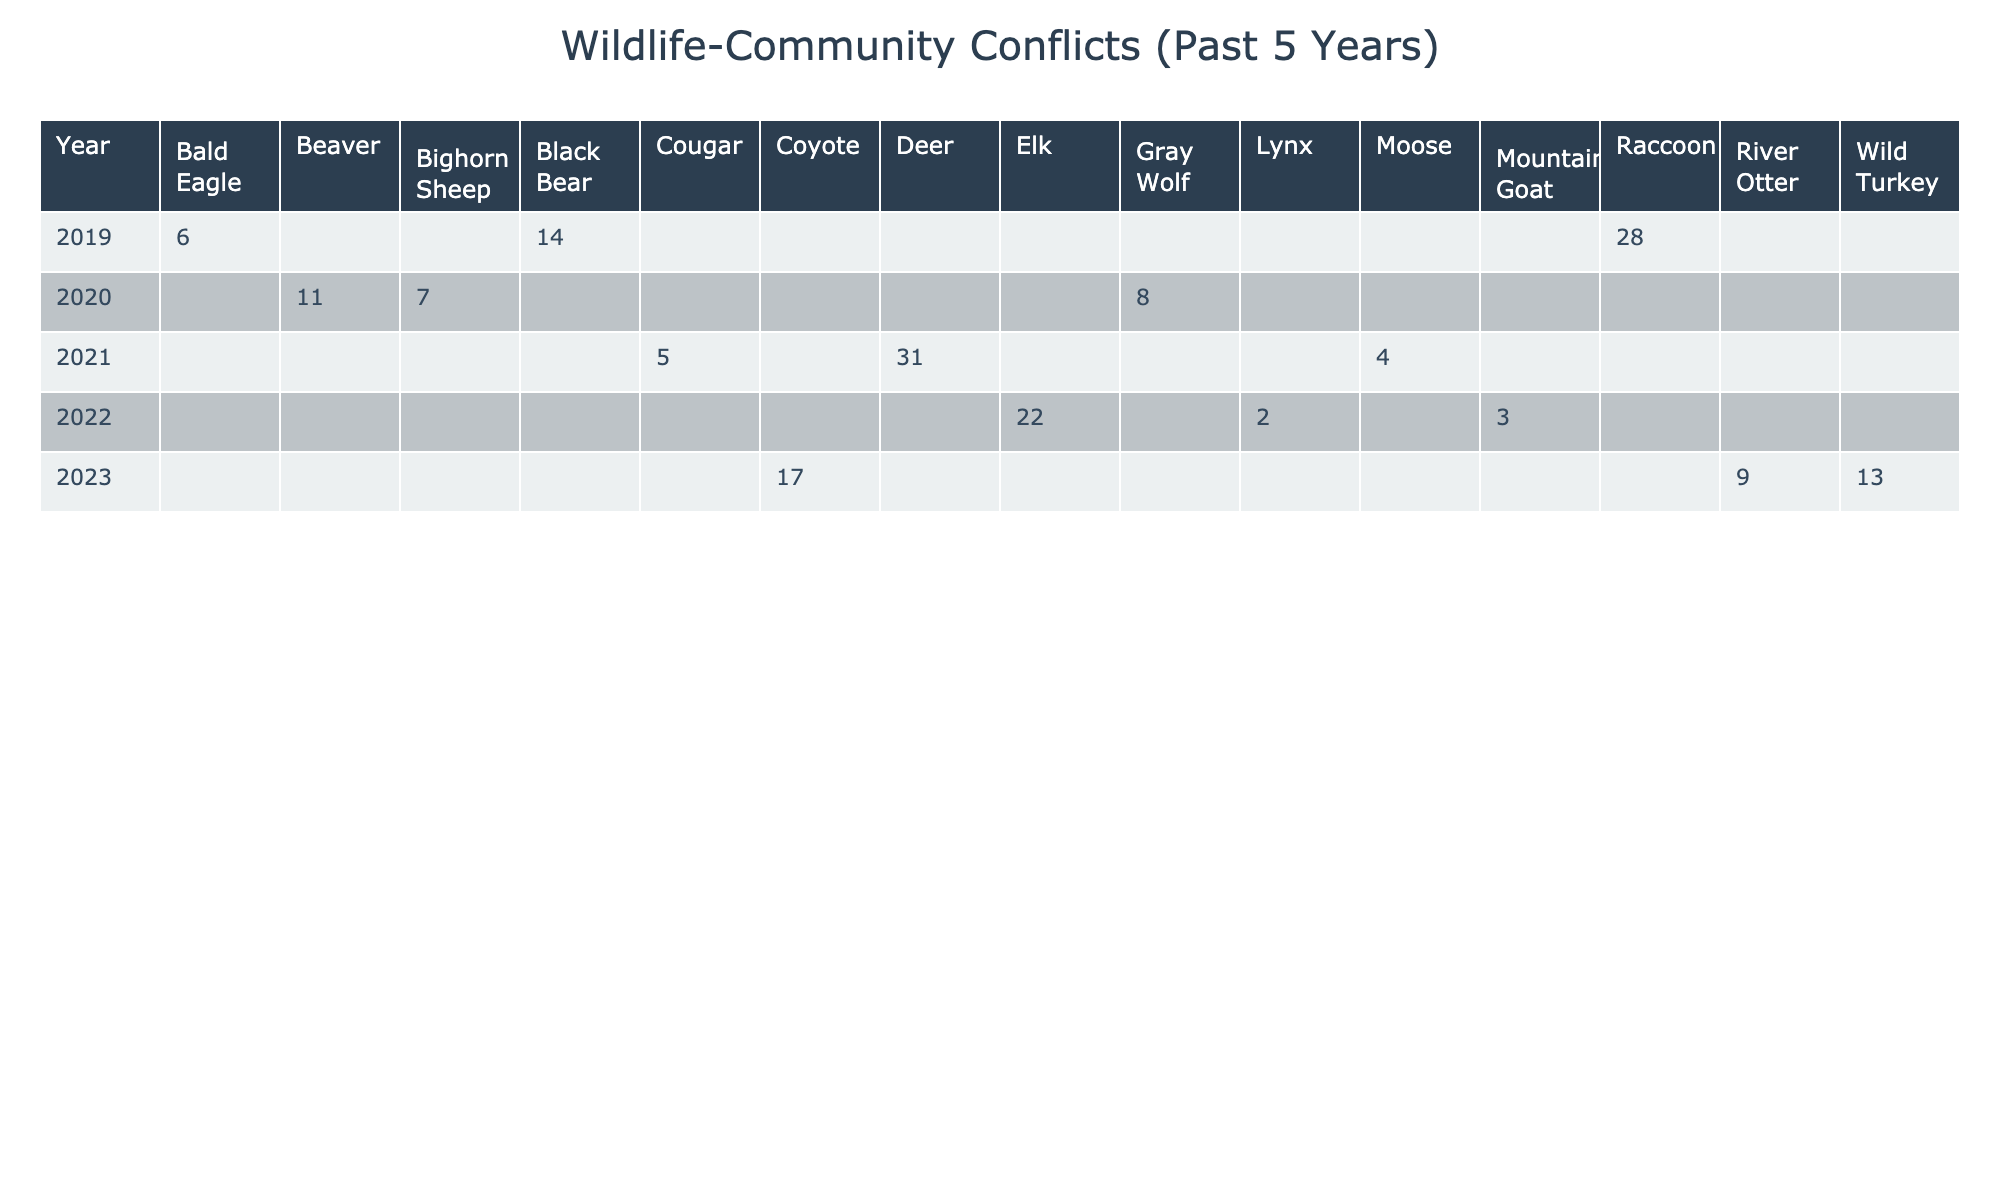What species had the highest number of reported incidents in 2021? By looking at the table under the year 2021, I can see that the Deer species had the highest number of reported incidents, which is 31.
Answer: Deer How many total incidents were reported for Black Bear conflicts over the 5 years? The Black Bear had 14 incidents in 2019, and no other entries are listed for the other years. Therefore, the total incidents for Black Bear is 14.
Answer: 14 What was the average number of incidents for Elk conflicts over the years they were reported? The Elk species had incidents reported only in 2022 with a total of 22 incidents. Since there is only one value, the average is simply 22.
Answer: 22 Which year saw the lowest number of conflicts reported? Analyzing the incidents across all years, the lowest number of reported conflicts is in 2021, with only 5 incidents reported.
Answer: 2021 Did conflicts involving Coyotes increase from 2022 to 2023? In 2022, Coyote conflicts were not reported, as the incident data shows only River Otter conflicts; hence, there are no prior incidents to compare with for Coyotes. Thus, I cannot determine an increase or decrease.
Answer: No What is the total number of incidents reported for livestock predation by Gray Wolves? The table shows that Gray Wolves had 8 incidents reported in 2020 for livestock predation, which is the only entry for this conflict type. Therefore, it totals 8 incidents.
Answer: 8 Which conflict type had the highest number of incidents in the past five years? By reviewing the incidents across all conflict types, the conflict type with the highest incidents is Crop Damage, with a total of 14 incidents reported for Black Bears in 2019.
Answer: Crop Damage How many conflicts involved human encounters in total? The table shows that there was 1 entry for human encounters with Cougars, which reported 5 incidents in 2021, hence the total incidents for human encounters is 5.
Answer: 5 Which wildlife species experienced property damage conflicts and how many incidents were reported? The Elk species experienced property damage conflicts in 2022 with a total of 22 incidents reported.
Answer: Elk, 22 Compare the total number of incidents reported for Raccoon conflicts with Coyote conflicts over the years. Raccoons had 28 incidents in 2019, and Coyotes had 17 incidents in 2023. Summing these gives Raccoons 28 and Coyotes 17, leading to a difference of 11 more incidents for Raccoons.
Answer: Raccoons had 11 more incidents than Coyotes 